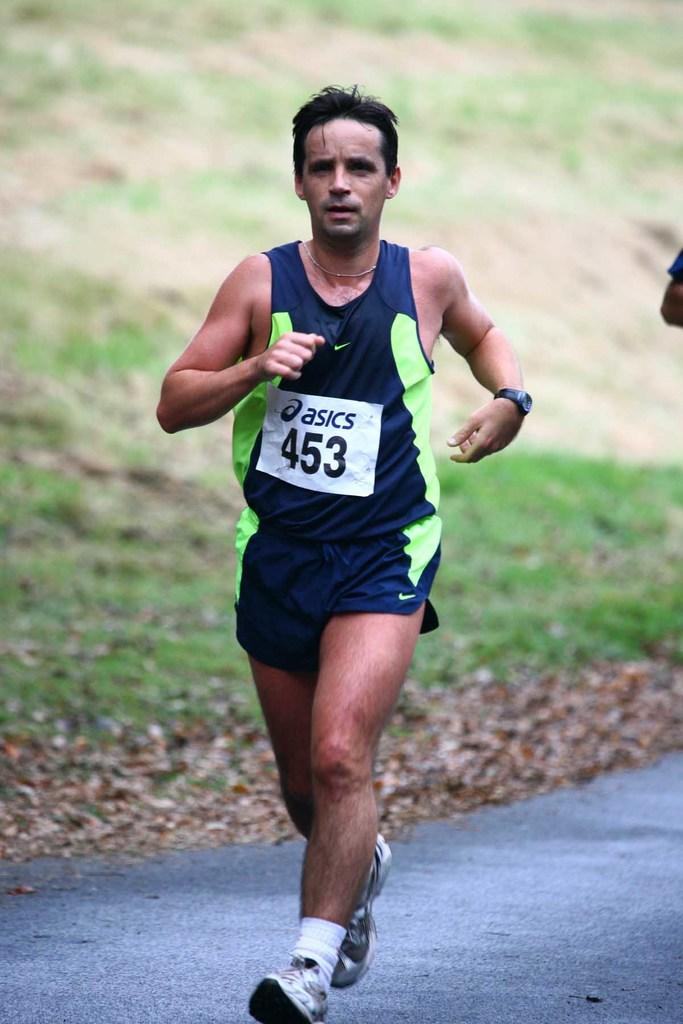<image>
Render a clear and concise summary of the photo. A man is running with a number sign from Asics on his shirt. 